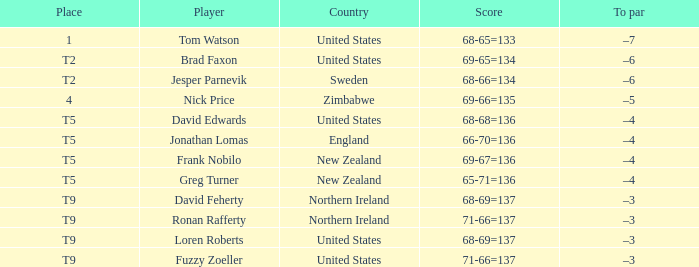Who is the golfer that golfs for Northern Ireland? David Feherty, Ronan Rafferty. 